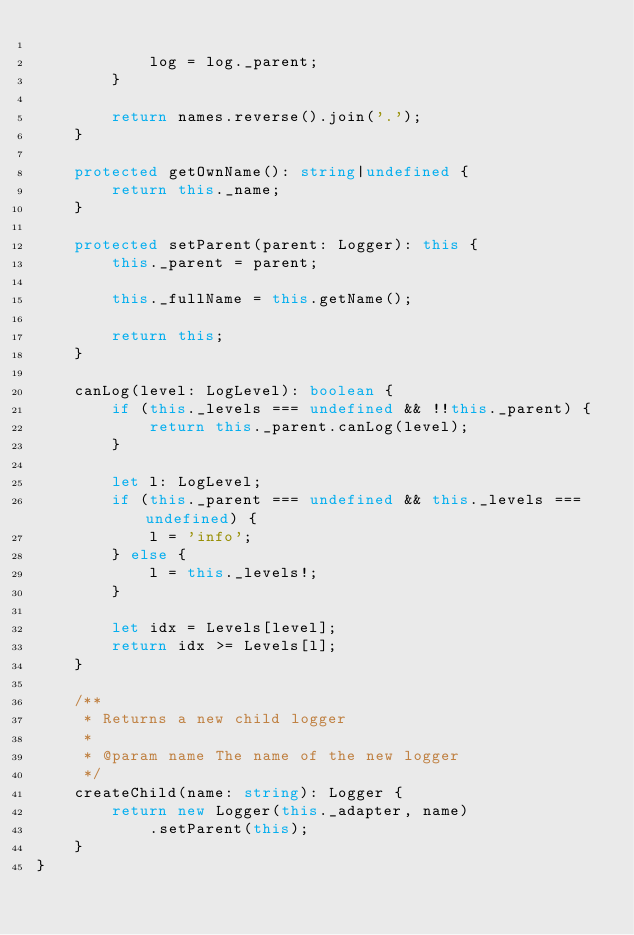<code> <loc_0><loc_0><loc_500><loc_500><_TypeScript_>            
            log = log._parent;
        }
        
        return names.reverse().join('.');
    }
    
    protected getOwnName(): string|undefined {
        return this._name;
    }
    
    protected setParent(parent: Logger): this {
        this._parent = parent;
        
        this._fullName = this.getName();
        
        return this;
    }
    
    canLog(level: LogLevel): boolean {
        if (this._levels === undefined && !!this._parent) {
            return this._parent.canLog(level); 
        }
        
        let l: LogLevel;
        if (this._parent === undefined && this._levels === undefined) {
            l = 'info';
        } else {
            l = this._levels!;
        }

        let idx = Levels[level];
        return idx >= Levels[l];
    }
    
    /**
     * Returns a new child logger
     * 
     * @param name The name of the new logger
     */
    createChild(name: string): Logger {
        return new Logger(this._adapter, name)
            .setParent(this);
    }
}
</code> 